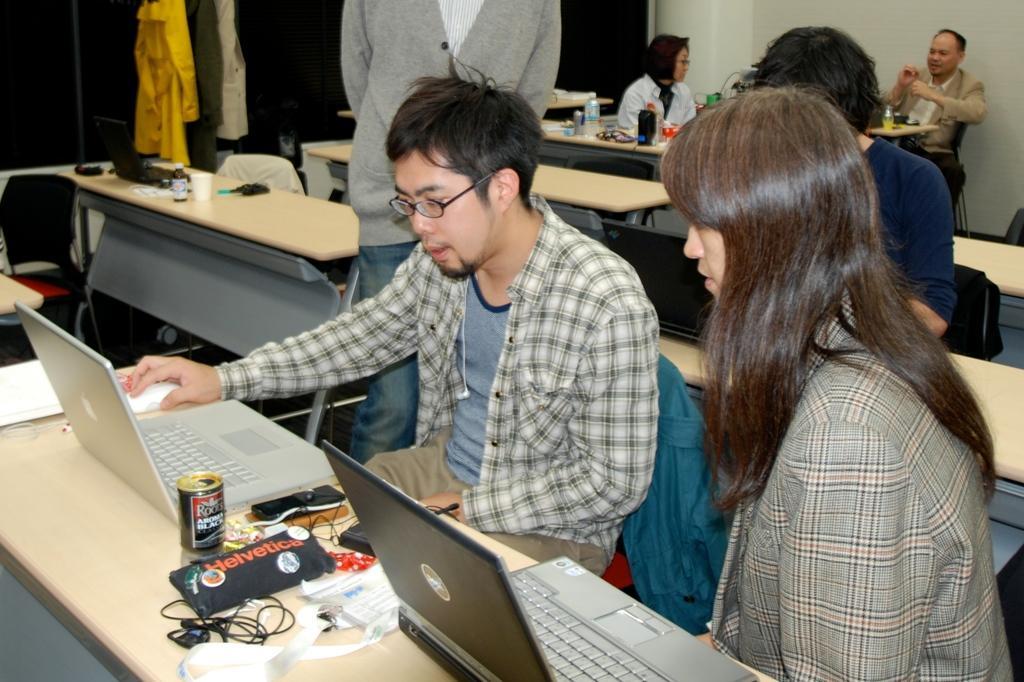Can you describe this image briefly? As we can see in the image there are few people sitting and one person standing. There are tables and chairs. On this table there are laptops and wire. 